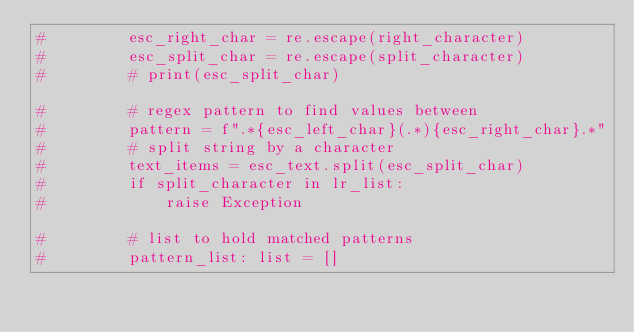Convert code to text. <code><loc_0><loc_0><loc_500><loc_500><_Python_>#         esc_right_char = re.escape(right_character)
#         esc_split_char = re.escape(split_character)
#         # print(esc_split_char)

#         # regex pattern to find values between
#         pattern = f".*{esc_left_char}(.*){esc_right_char}.*"
#         # split string by a character
#         text_items = esc_text.split(esc_split_char)
#         if split_character in lr_list:
#             raise Exception

#         # list to hold matched patterns
#         pattern_list: list = []
</code> 